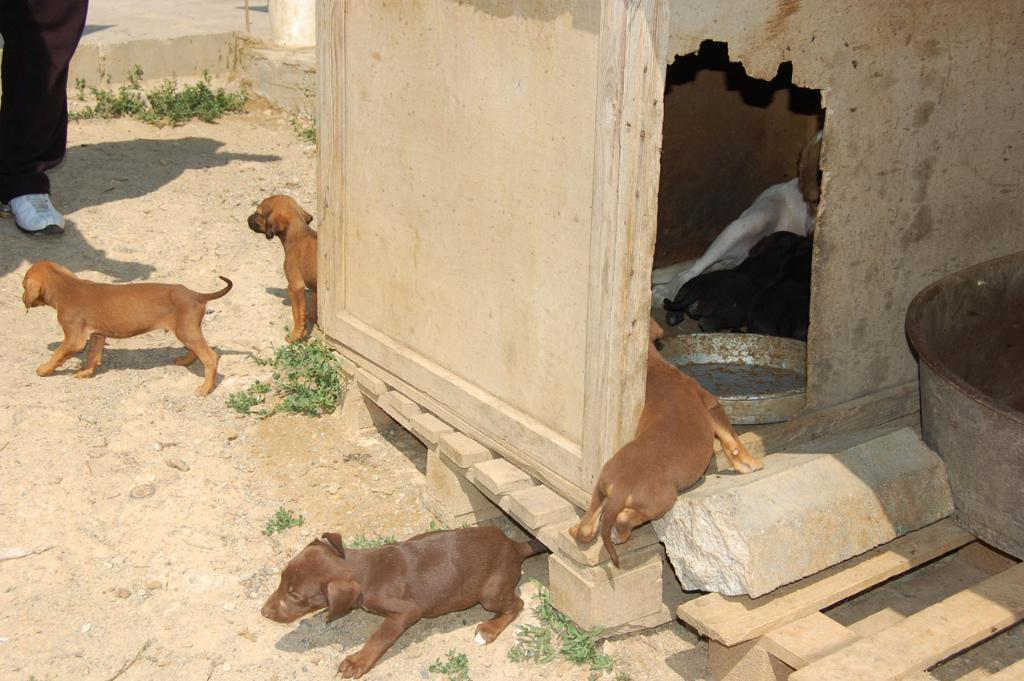What structure is located on the right side of the image? There is a shed on the right side of the image. What type of animals are present in the image? Dogs are present in the image. What part of a person can be seen on the left side of the image? There is a person's leg on the left side of the image. What objects are used for holding or carrying items in the image? Trays are visible in the image. What type of riddle is being solved by the dogs in the image? There is no riddle being solved by the dogs in the image; they are simply present. Can you tell me how many hydrants are visible in the image? There are no hydrants present in the image. What advertisement is being displayed on the shed in the image? There is no advertisement displayed on the shed in the image; it is just a shed. 